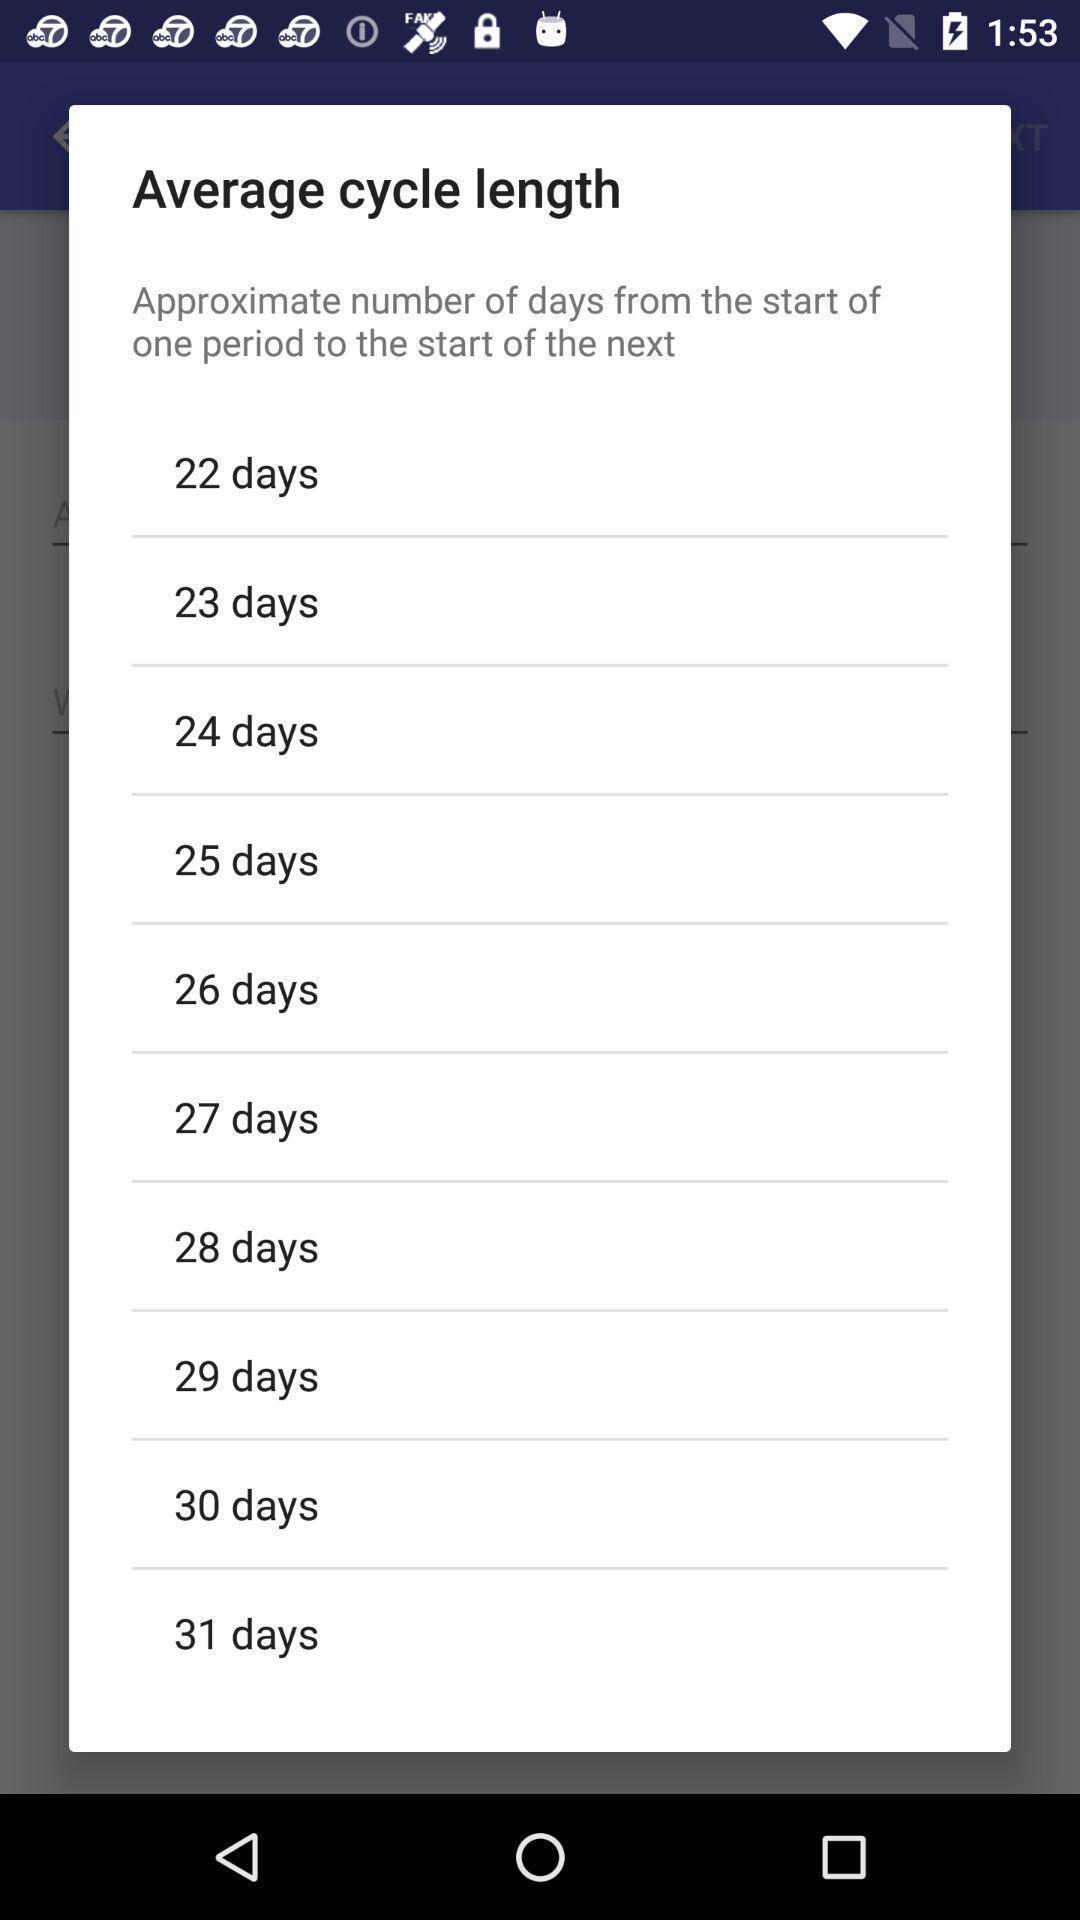Describe the visual elements of this screenshot. Pop-up showing list of period cycle length. 